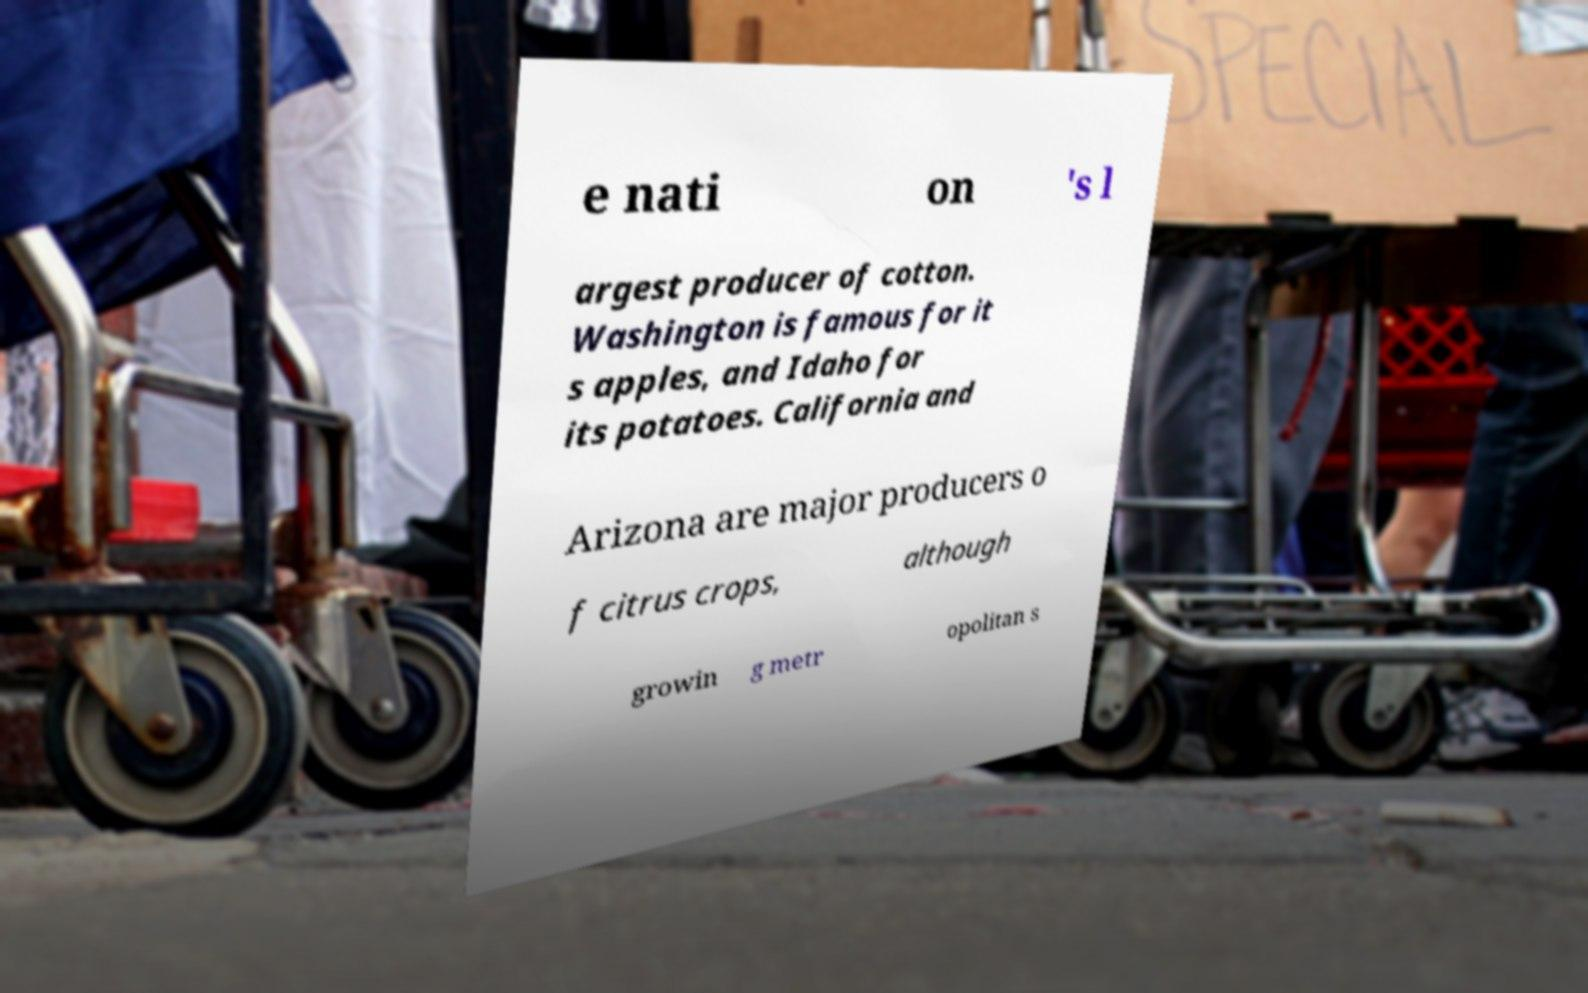For documentation purposes, I need the text within this image transcribed. Could you provide that? e nati on 's l argest producer of cotton. Washington is famous for it s apples, and Idaho for its potatoes. California and Arizona are major producers o f citrus crops, although growin g metr opolitan s 